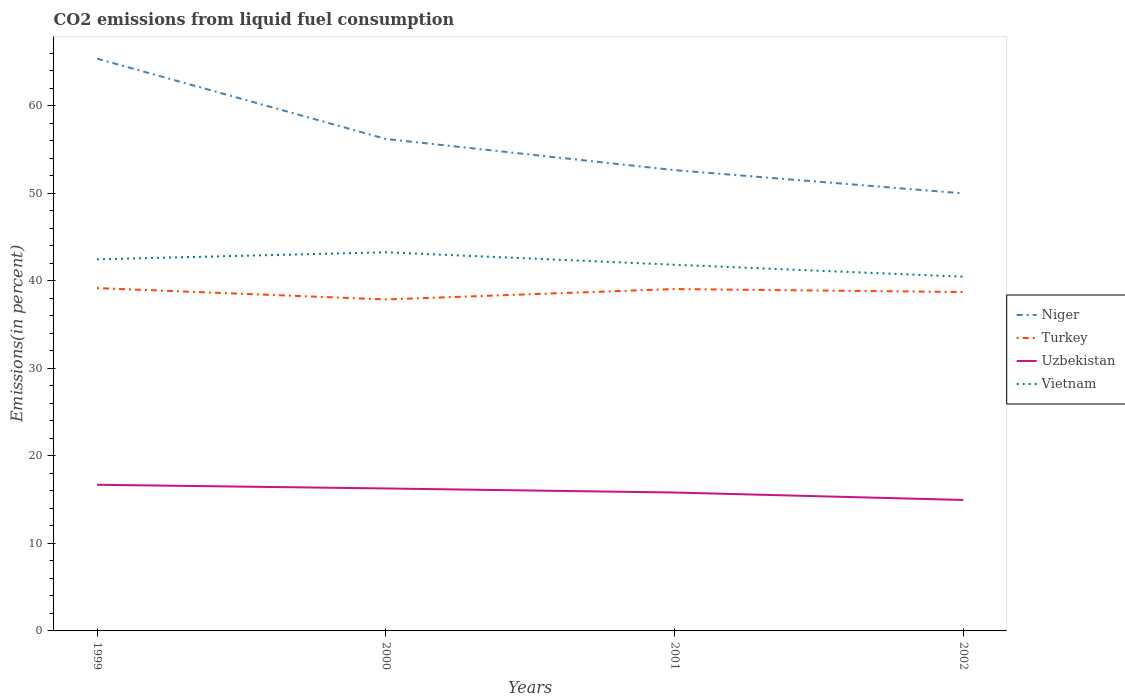How many different coloured lines are there?
Offer a very short reply. 4. Does the line corresponding to Niger intersect with the line corresponding to Turkey?
Make the answer very short. No. What is the total total CO2 emitted in Uzbekistan in the graph?
Make the answer very short. 1.74. What is the difference between the highest and the second highest total CO2 emitted in Vietnam?
Ensure brevity in your answer.  2.79. How many lines are there?
Offer a terse response. 4. Are the values on the major ticks of Y-axis written in scientific E-notation?
Make the answer very short. No. Where does the legend appear in the graph?
Make the answer very short. Center right. How are the legend labels stacked?
Offer a terse response. Vertical. What is the title of the graph?
Your answer should be compact. CO2 emissions from liquid fuel consumption. Does "Cambodia" appear as one of the legend labels in the graph?
Offer a very short reply. No. What is the label or title of the X-axis?
Ensure brevity in your answer.  Years. What is the label or title of the Y-axis?
Your answer should be compact. Emissions(in percent). What is the Emissions(in percent) in Niger in 1999?
Give a very brief answer. 65.4. What is the Emissions(in percent) in Turkey in 1999?
Keep it short and to the point. 39.18. What is the Emissions(in percent) of Uzbekistan in 1999?
Offer a terse response. 16.7. What is the Emissions(in percent) in Vietnam in 1999?
Keep it short and to the point. 42.47. What is the Emissions(in percent) of Niger in 2000?
Provide a short and direct response. 56.22. What is the Emissions(in percent) of Turkey in 2000?
Ensure brevity in your answer.  37.88. What is the Emissions(in percent) of Uzbekistan in 2000?
Your answer should be very brief. 16.28. What is the Emissions(in percent) in Vietnam in 2000?
Offer a terse response. 43.27. What is the Emissions(in percent) in Niger in 2001?
Make the answer very short. 52.66. What is the Emissions(in percent) of Turkey in 2001?
Your answer should be compact. 39.07. What is the Emissions(in percent) in Uzbekistan in 2001?
Provide a short and direct response. 15.82. What is the Emissions(in percent) of Vietnam in 2001?
Offer a very short reply. 41.85. What is the Emissions(in percent) of Turkey in 2002?
Offer a terse response. 38.73. What is the Emissions(in percent) in Uzbekistan in 2002?
Ensure brevity in your answer.  14.97. What is the Emissions(in percent) of Vietnam in 2002?
Your response must be concise. 40.48. Across all years, what is the maximum Emissions(in percent) in Niger?
Your response must be concise. 65.4. Across all years, what is the maximum Emissions(in percent) in Turkey?
Ensure brevity in your answer.  39.18. Across all years, what is the maximum Emissions(in percent) in Uzbekistan?
Keep it short and to the point. 16.7. Across all years, what is the maximum Emissions(in percent) of Vietnam?
Keep it short and to the point. 43.27. Across all years, what is the minimum Emissions(in percent) of Niger?
Offer a very short reply. 50. Across all years, what is the minimum Emissions(in percent) in Turkey?
Your answer should be very brief. 37.88. Across all years, what is the minimum Emissions(in percent) of Uzbekistan?
Offer a very short reply. 14.97. Across all years, what is the minimum Emissions(in percent) in Vietnam?
Make the answer very short. 40.48. What is the total Emissions(in percent) in Niger in the graph?
Ensure brevity in your answer.  224.28. What is the total Emissions(in percent) in Turkey in the graph?
Your answer should be very brief. 154.85. What is the total Emissions(in percent) of Uzbekistan in the graph?
Your answer should be compact. 63.76. What is the total Emissions(in percent) in Vietnam in the graph?
Offer a terse response. 168.06. What is the difference between the Emissions(in percent) in Niger in 1999 and that in 2000?
Your answer should be compact. 9.18. What is the difference between the Emissions(in percent) in Turkey in 1999 and that in 2000?
Keep it short and to the point. 1.3. What is the difference between the Emissions(in percent) of Uzbekistan in 1999 and that in 2000?
Provide a succinct answer. 0.42. What is the difference between the Emissions(in percent) of Vietnam in 1999 and that in 2000?
Your answer should be compact. -0.81. What is the difference between the Emissions(in percent) in Niger in 1999 and that in 2001?
Keep it short and to the point. 12.74. What is the difference between the Emissions(in percent) of Turkey in 1999 and that in 2001?
Your response must be concise. 0.11. What is the difference between the Emissions(in percent) of Uzbekistan in 1999 and that in 2001?
Offer a very short reply. 0.88. What is the difference between the Emissions(in percent) of Vietnam in 1999 and that in 2001?
Provide a short and direct response. 0.62. What is the difference between the Emissions(in percent) in Niger in 1999 and that in 2002?
Ensure brevity in your answer.  15.4. What is the difference between the Emissions(in percent) in Turkey in 1999 and that in 2002?
Make the answer very short. 0.45. What is the difference between the Emissions(in percent) in Uzbekistan in 1999 and that in 2002?
Make the answer very short. 1.74. What is the difference between the Emissions(in percent) in Vietnam in 1999 and that in 2002?
Make the answer very short. 1.99. What is the difference between the Emissions(in percent) in Niger in 2000 and that in 2001?
Provide a succinct answer. 3.56. What is the difference between the Emissions(in percent) in Turkey in 2000 and that in 2001?
Your answer should be very brief. -1.19. What is the difference between the Emissions(in percent) in Uzbekistan in 2000 and that in 2001?
Keep it short and to the point. 0.46. What is the difference between the Emissions(in percent) of Vietnam in 2000 and that in 2001?
Your answer should be compact. 1.42. What is the difference between the Emissions(in percent) in Niger in 2000 and that in 2002?
Give a very brief answer. 6.22. What is the difference between the Emissions(in percent) of Turkey in 2000 and that in 2002?
Offer a terse response. -0.85. What is the difference between the Emissions(in percent) of Uzbekistan in 2000 and that in 2002?
Provide a succinct answer. 1.31. What is the difference between the Emissions(in percent) in Vietnam in 2000 and that in 2002?
Offer a terse response. 2.79. What is the difference between the Emissions(in percent) of Niger in 2001 and that in 2002?
Your answer should be very brief. 2.66. What is the difference between the Emissions(in percent) in Turkey in 2001 and that in 2002?
Your answer should be very brief. 0.34. What is the difference between the Emissions(in percent) of Uzbekistan in 2001 and that in 2002?
Keep it short and to the point. 0.85. What is the difference between the Emissions(in percent) in Vietnam in 2001 and that in 2002?
Keep it short and to the point. 1.37. What is the difference between the Emissions(in percent) in Niger in 1999 and the Emissions(in percent) in Turkey in 2000?
Your answer should be compact. 27.52. What is the difference between the Emissions(in percent) in Niger in 1999 and the Emissions(in percent) in Uzbekistan in 2000?
Your response must be concise. 49.12. What is the difference between the Emissions(in percent) in Niger in 1999 and the Emissions(in percent) in Vietnam in 2000?
Make the answer very short. 22.13. What is the difference between the Emissions(in percent) in Turkey in 1999 and the Emissions(in percent) in Uzbekistan in 2000?
Provide a short and direct response. 22.9. What is the difference between the Emissions(in percent) of Turkey in 1999 and the Emissions(in percent) of Vietnam in 2000?
Keep it short and to the point. -4.09. What is the difference between the Emissions(in percent) in Uzbekistan in 1999 and the Emissions(in percent) in Vietnam in 2000?
Provide a short and direct response. -26.57. What is the difference between the Emissions(in percent) in Niger in 1999 and the Emissions(in percent) in Turkey in 2001?
Give a very brief answer. 26.33. What is the difference between the Emissions(in percent) in Niger in 1999 and the Emissions(in percent) in Uzbekistan in 2001?
Your answer should be compact. 49.58. What is the difference between the Emissions(in percent) of Niger in 1999 and the Emissions(in percent) of Vietnam in 2001?
Offer a very short reply. 23.55. What is the difference between the Emissions(in percent) in Turkey in 1999 and the Emissions(in percent) in Uzbekistan in 2001?
Keep it short and to the point. 23.36. What is the difference between the Emissions(in percent) of Turkey in 1999 and the Emissions(in percent) of Vietnam in 2001?
Provide a short and direct response. -2.67. What is the difference between the Emissions(in percent) of Uzbekistan in 1999 and the Emissions(in percent) of Vietnam in 2001?
Provide a short and direct response. -25.14. What is the difference between the Emissions(in percent) of Niger in 1999 and the Emissions(in percent) of Turkey in 2002?
Give a very brief answer. 26.67. What is the difference between the Emissions(in percent) in Niger in 1999 and the Emissions(in percent) in Uzbekistan in 2002?
Make the answer very short. 50.43. What is the difference between the Emissions(in percent) of Niger in 1999 and the Emissions(in percent) of Vietnam in 2002?
Provide a succinct answer. 24.92. What is the difference between the Emissions(in percent) of Turkey in 1999 and the Emissions(in percent) of Uzbekistan in 2002?
Provide a short and direct response. 24.21. What is the difference between the Emissions(in percent) of Turkey in 1999 and the Emissions(in percent) of Vietnam in 2002?
Offer a very short reply. -1.3. What is the difference between the Emissions(in percent) of Uzbekistan in 1999 and the Emissions(in percent) of Vietnam in 2002?
Provide a short and direct response. -23.78. What is the difference between the Emissions(in percent) in Niger in 2000 and the Emissions(in percent) in Turkey in 2001?
Offer a terse response. 17.15. What is the difference between the Emissions(in percent) in Niger in 2000 and the Emissions(in percent) in Uzbekistan in 2001?
Ensure brevity in your answer.  40.4. What is the difference between the Emissions(in percent) in Niger in 2000 and the Emissions(in percent) in Vietnam in 2001?
Offer a very short reply. 14.38. What is the difference between the Emissions(in percent) in Turkey in 2000 and the Emissions(in percent) in Uzbekistan in 2001?
Offer a very short reply. 22.06. What is the difference between the Emissions(in percent) of Turkey in 2000 and the Emissions(in percent) of Vietnam in 2001?
Provide a succinct answer. -3.97. What is the difference between the Emissions(in percent) of Uzbekistan in 2000 and the Emissions(in percent) of Vietnam in 2001?
Offer a very short reply. -25.57. What is the difference between the Emissions(in percent) in Niger in 2000 and the Emissions(in percent) in Turkey in 2002?
Give a very brief answer. 17.49. What is the difference between the Emissions(in percent) of Niger in 2000 and the Emissions(in percent) of Uzbekistan in 2002?
Offer a terse response. 41.26. What is the difference between the Emissions(in percent) of Niger in 2000 and the Emissions(in percent) of Vietnam in 2002?
Keep it short and to the point. 15.74. What is the difference between the Emissions(in percent) in Turkey in 2000 and the Emissions(in percent) in Uzbekistan in 2002?
Offer a terse response. 22.91. What is the difference between the Emissions(in percent) in Turkey in 2000 and the Emissions(in percent) in Vietnam in 2002?
Your response must be concise. -2.6. What is the difference between the Emissions(in percent) of Uzbekistan in 2000 and the Emissions(in percent) of Vietnam in 2002?
Offer a terse response. -24.2. What is the difference between the Emissions(in percent) of Niger in 2001 and the Emissions(in percent) of Turkey in 2002?
Offer a very short reply. 13.93. What is the difference between the Emissions(in percent) of Niger in 2001 and the Emissions(in percent) of Uzbekistan in 2002?
Provide a short and direct response. 37.69. What is the difference between the Emissions(in percent) of Niger in 2001 and the Emissions(in percent) of Vietnam in 2002?
Make the answer very short. 12.18. What is the difference between the Emissions(in percent) in Turkey in 2001 and the Emissions(in percent) in Uzbekistan in 2002?
Keep it short and to the point. 24.1. What is the difference between the Emissions(in percent) in Turkey in 2001 and the Emissions(in percent) in Vietnam in 2002?
Provide a succinct answer. -1.41. What is the difference between the Emissions(in percent) in Uzbekistan in 2001 and the Emissions(in percent) in Vietnam in 2002?
Give a very brief answer. -24.66. What is the average Emissions(in percent) in Niger per year?
Offer a very short reply. 56.07. What is the average Emissions(in percent) of Turkey per year?
Keep it short and to the point. 38.71. What is the average Emissions(in percent) of Uzbekistan per year?
Your response must be concise. 15.94. What is the average Emissions(in percent) of Vietnam per year?
Your answer should be very brief. 42.02. In the year 1999, what is the difference between the Emissions(in percent) of Niger and Emissions(in percent) of Turkey?
Your answer should be compact. 26.22. In the year 1999, what is the difference between the Emissions(in percent) of Niger and Emissions(in percent) of Uzbekistan?
Provide a short and direct response. 48.7. In the year 1999, what is the difference between the Emissions(in percent) of Niger and Emissions(in percent) of Vietnam?
Your answer should be compact. 22.93. In the year 1999, what is the difference between the Emissions(in percent) of Turkey and Emissions(in percent) of Uzbekistan?
Keep it short and to the point. 22.48. In the year 1999, what is the difference between the Emissions(in percent) of Turkey and Emissions(in percent) of Vietnam?
Offer a terse response. -3.29. In the year 1999, what is the difference between the Emissions(in percent) in Uzbekistan and Emissions(in percent) in Vietnam?
Your response must be concise. -25.76. In the year 2000, what is the difference between the Emissions(in percent) in Niger and Emissions(in percent) in Turkey?
Offer a terse response. 18.34. In the year 2000, what is the difference between the Emissions(in percent) of Niger and Emissions(in percent) of Uzbekistan?
Give a very brief answer. 39.94. In the year 2000, what is the difference between the Emissions(in percent) in Niger and Emissions(in percent) in Vietnam?
Your answer should be compact. 12.95. In the year 2000, what is the difference between the Emissions(in percent) of Turkey and Emissions(in percent) of Uzbekistan?
Your answer should be very brief. 21.6. In the year 2000, what is the difference between the Emissions(in percent) of Turkey and Emissions(in percent) of Vietnam?
Give a very brief answer. -5.39. In the year 2000, what is the difference between the Emissions(in percent) in Uzbekistan and Emissions(in percent) in Vietnam?
Your answer should be very brief. -26.99. In the year 2001, what is the difference between the Emissions(in percent) of Niger and Emissions(in percent) of Turkey?
Your answer should be very brief. 13.59. In the year 2001, what is the difference between the Emissions(in percent) of Niger and Emissions(in percent) of Uzbekistan?
Give a very brief answer. 36.84. In the year 2001, what is the difference between the Emissions(in percent) in Niger and Emissions(in percent) in Vietnam?
Give a very brief answer. 10.81. In the year 2001, what is the difference between the Emissions(in percent) in Turkey and Emissions(in percent) in Uzbekistan?
Give a very brief answer. 23.25. In the year 2001, what is the difference between the Emissions(in percent) of Turkey and Emissions(in percent) of Vietnam?
Offer a terse response. -2.78. In the year 2001, what is the difference between the Emissions(in percent) in Uzbekistan and Emissions(in percent) in Vietnam?
Make the answer very short. -26.03. In the year 2002, what is the difference between the Emissions(in percent) in Niger and Emissions(in percent) in Turkey?
Your answer should be compact. 11.27. In the year 2002, what is the difference between the Emissions(in percent) of Niger and Emissions(in percent) of Uzbekistan?
Your answer should be very brief. 35.03. In the year 2002, what is the difference between the Emissions(in percent) of Niger and Emissions(in percent) of Vietnam?
Keep it short and to the point. 9.52. In the year 2002, what is the difference between the Emissions(in percent) in Turkey and Emissions(in percent) in Uzbekistan?
Keep it short and to the point. 23.76. In the year 2002, what is the difference between the Emissions(in percent) in Turkey and Emissions(in percent) in Vietnam?
Give a very brief answer. -1.75. In the year 2002, what is the difference between the Emissions(in percent) in Uzbekistan and Emissions(in percent) in Vietnam?
Make the answer very short. -25.51. What is the ratio of the Emissions(in percent) of Niger in 1999 to that in 2000?
Make the answer very short. 1.16. What is the ratio of the Emissions(in percent) in Turkey in 1999 to that in 2000?
Provide a short and direct response. 1.03. What is the ratio of the Emissions(in percent) of Vietnam in 1999 to that in 2000?
Your answer should be compact. 0.98. What is the ratio of the Emissions(in percent) of Niger in 1999 to that in 2001?
Provide a short and direct response. 1.24. What is the ratio of the Emissions(in percent) in Turkey in 1999 to that in 2001?
Give a very brief answer. 1. What is the ratio of the Emissions(in percent) in Uzbekistan in 1999 to that in 2001?
Your answer should be compact. 1.06. What is the ratio of the Emissions(in percent) of Vietnam in 1999 to that in 2001?
Keep it short and to the point. 1.01. What is the ratio of the Emissions(in percent) of Niger in 1999 to that in 2002?
Your answer should be very brief. 1.31. What is the ratio of the Emissions(in percent) of Turkey in 1999 to that in 2002?
Your response must be concise. 1.01. What is the ratio of the Emissions(in percent) in Uzbekistan in 1999 to that in 2002?
Provide a succinct answer. 1.12. What is the ratio of the Emissions(in percent) in Vietnam in 1999 to that in 2002?
Make the answer very short. 1.05. What is the ratio of the Emissions(in percent) of Niger in 2000 to that in 2001?
Make the answer very short. 1.07. What is the ratio of the Emissions(in percent) of Turkey in 2000 to that in 2001?
Ensure brevity in your answer.  0.97. What is the ratio of the Emissions(in percent) of Uzbekistan in 2000 to that in 2001?
Your answer should be compact. 1.03. What is the ratio of the Emissions(in percent) of Vietnam in 2000 to that in 2001?
Ensure brevity in your answer.  1.03. What is the ratio of the Emissions(in percent) of Niger in 2000 to that in 2002?
Offer a terse response. 1.12. What is the ratio of the Emissions(in percent) in Turkey in 2000 to that in 2002?
Your answer should be very brief. 0.98. What is the ratio of the Emissions(in percent) of Uzbekistan in 2000 to that in 2002?
Offer a terse response. 1.09. What is the ratio of the Emissions(in percent) in Vietnam in 2000 to that in 2002?
Your response must be concise. 1.07. What is the ratio of the Emissions(in percent) in Niger in 2001 to that in 2002?
Your answer should be very brief. 1.05. What is the ratio of the Emissions(in percent) in Turkey in 2001 to that in 2002?
Give a very brief answer. 1.01. What is the ratio of the Emissions(in percent) in Uzbekistan in 2001 to that in 2002?
Make the answer very short. 1.06. What is the ratio of the Emissions(in percent) in Vietnam in 2001 to that in 2002?
Keep it short and to the point. 1.03. What is the difference between the highest and the second highest Emissions(in percent) in Niger?
Your answer should be very brief. 9.18. What is the difference between the highest and the second highest Emissions(in percent) in Turkey?
Offer a very short reply. 0.11. What is the difference between the highest and the second highest Emissions(in percent) in Uzbekistan?
Your response must be concise. 0.42. What is the difference between the highest and the second highest Emissions(in percent) of Vietnam?
Offer a very short reply. 0.81. What is the difference between the highest and the lowest Emissions(in percent) of Niger?
Make the answer very short. 15.4. What is the difference between the highest and the lowest Emissions(in percent) in Turkey?
Provide a succinct answer. 1.3. What is the difference between the highest and the lowest Emissions(in percent) in Uzbekistan?
Keep it short and to the point. 1.74. What is the difference between the highest and the lowest Emissions(in percent) of Vietnam?
Ensure brevity in your answer.  2.79. 